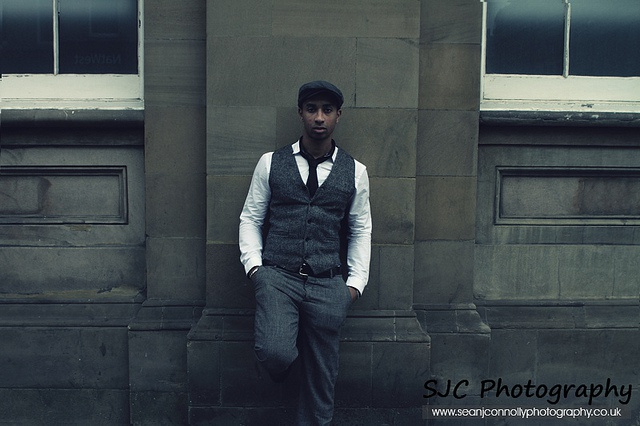Describe the objects in this image and their specific colors. I can see people in gray, black, blue, and lightgray tones and tie in gray, black, darkgray, and darkblue tones in this image. 